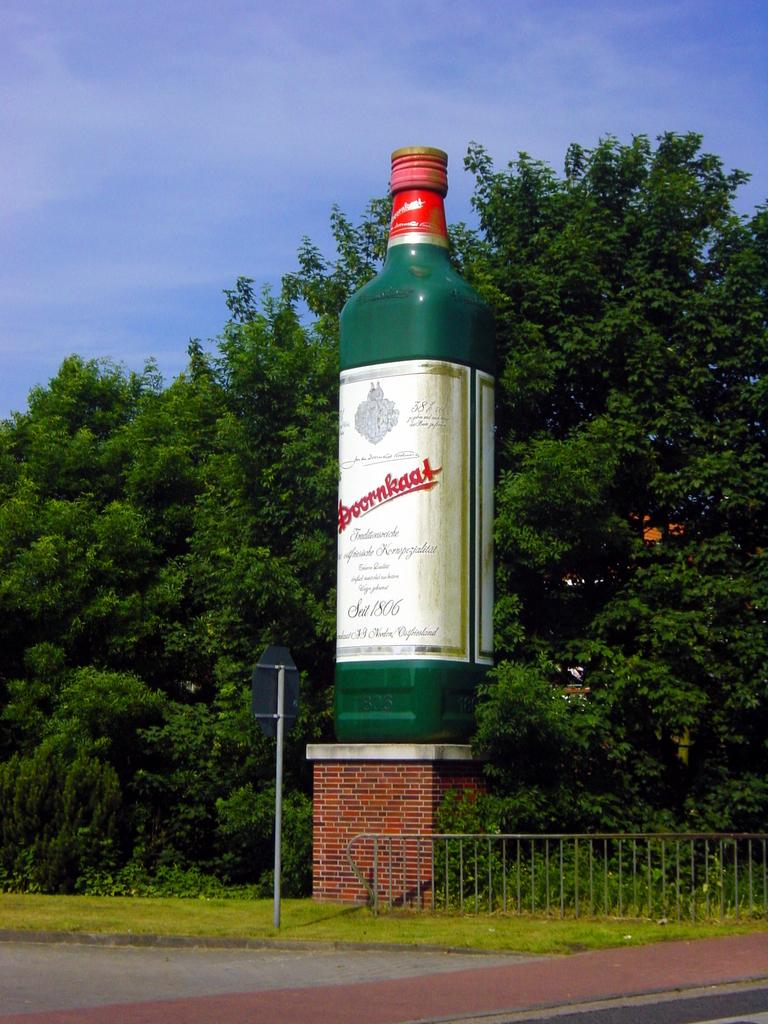<image>
Give a short and clear explanation of the subsequent image. A large bottle on a brick pedestal has the year 1806 on it. 